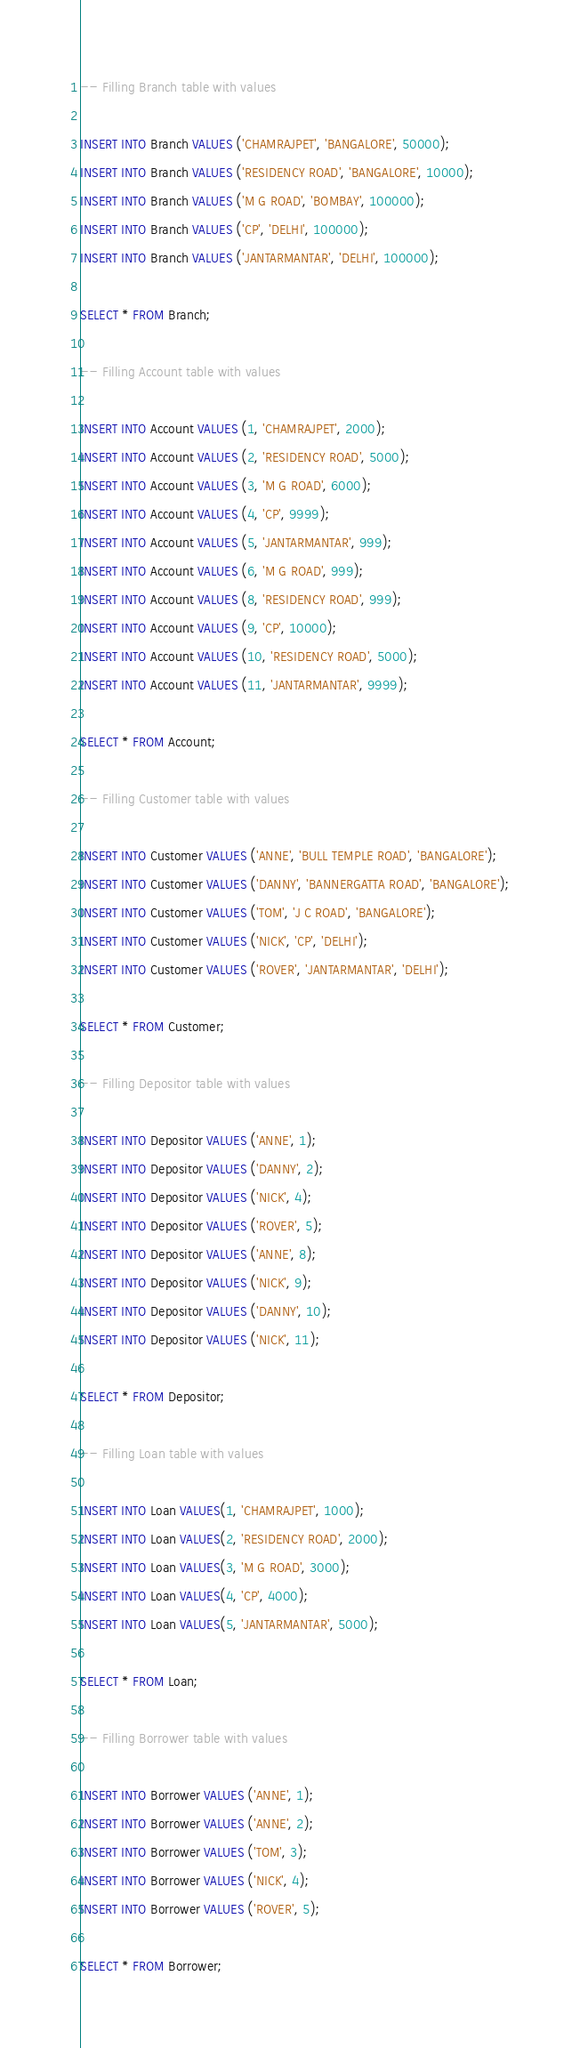Convert code to text. <code><loc_0><loc_0><loc_500><loc_500><_SQL_>-- Filling Branch table with values

INSERT INTO Branch VALUES ('CHAMRAJPET', 'BANGALORE', 50000);
INSERT INTO Branch VALUES ('RESIDENCY ROAD', 'BANGALORE', 10000);
INSERT INTO Branch VALUES ('M G ROAD', 'BOMBAY', 100000);
INSERT INTO Branch VALUES ('CP', 'DELHI', 100000);
INSERT INTO Branch VALUES ('JANTARMANTAR', 'DELHI', 100000);

SELECT * FROM Branch;

-- Filling Account table with values

INSERT INTO Account VALUES (1, 'CHAMRAJPET', 2000);
INSERT INTO Account VALUES (2, 'RESIDENCY ROAD', 5000);
INSERT INTO Account VALUES (3, 'M G ROAD', 6000);
INSERT INTO Account VALUES (4, 'CP', 9999);
INSERT INTO Account VALUES (5, 'JANTARMANTAR', 999);
INSERT INTO Account VALUES (6, 'M G ROAD', 999);
INSERT INTO Account VALUES (8, 'RESIDENCY ROAD', 999);
INSERT INTO Account VALUES (9, 'CP', 10000);
INSERT INTO Account VALUES (10, 'RESIDENCY ROAD', 5000);
INSERT INTO Account VALUES (11, 'JANTARMANTAR', 9999);

SELECT * FROM Account;

-- Filling Customer table with values

INSERT INTO Customer VALUES ('ANNE', 'BULL TEMPLE ROAD', 'BANGALORE');
INSERT INTO Customer VALUES ('DANNY', 'BANNERGATTA ROAD', 'BANGALORE');
INSERT INTO Customer VALUES ('TOM', 'J C ROAD', 'BANGALORE');
INSERT INTO Customer VALUES ('NICK', 'CP', 'DELHI');
INSERT INTO Customer VALUES ('ROVER', 'JANTARMANTAR', 'DELHI');

SELECT * FROM Customer;

-- Filling Depositor table with values

INSERT INTO Depositor VALUES ('ANNE', 1);
INSERT INTO Depositor VALUES ('DANNY', 2);
INSERT INTO Depositor VALUES ('NICK', 4);
INSERT INTO Depositor VALUES ('ROVER', 5);
INSERT INTO Depositor VALUES ('ANNE', 8);
INSERT INTO Depositor VALUES ('NICK', 9);
INSERT INTO Depositor VALUES ('DANNY', 10);
INSERT INTO Depositor VALUES ('NICK', 11);

SELECT * FROM Depositor;

-- Filling Loan table with values

INSERT INTO Loan VALUES(1, 'CHAMRAJPET', 1000);
INSERT INTO Loan VALUES(2, 'RESIDENCY ROAD', 2000);
INSERT INTO Loan VALUES(3, 'M G ROAD', 3000);
INSERT INTO Loan VALUES(4, 'CP', 4000);
INSERT INTO Loan VALUES(5, 'JANTARMANTAR', 5000);

SELECT * FROM Loan;

-- Filling Borrower table with values

INSERT INTO Borrower VALUES ('ANNE', 1);
INSERT INTO Borrower VALUES ('ANNE', 2);
INSERT INTO Borrower VALUES ('TOM', 3);
INSERT INTO Borrower VALUES ('NICK', 4);
INSERT INTO Borrower VALUES ('ROVER', 5);

SELECT * FROM Borrower;
</code> 